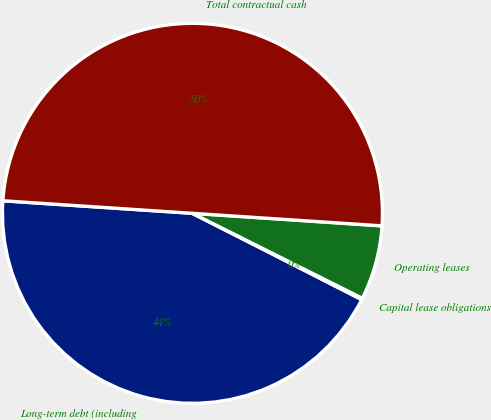Convert chart. <chart><loc_0><loc_0><loc_500><loc_500><pie_chart><fcel>Long-term debt (including<fcel>Capital lease obligations<fcel>Operating leases<fcel>Total contractual cash<nl><fcel>43.55%<fcel>0.12%<fcel>6.33%<fcel>50.0%<nl></chart> 